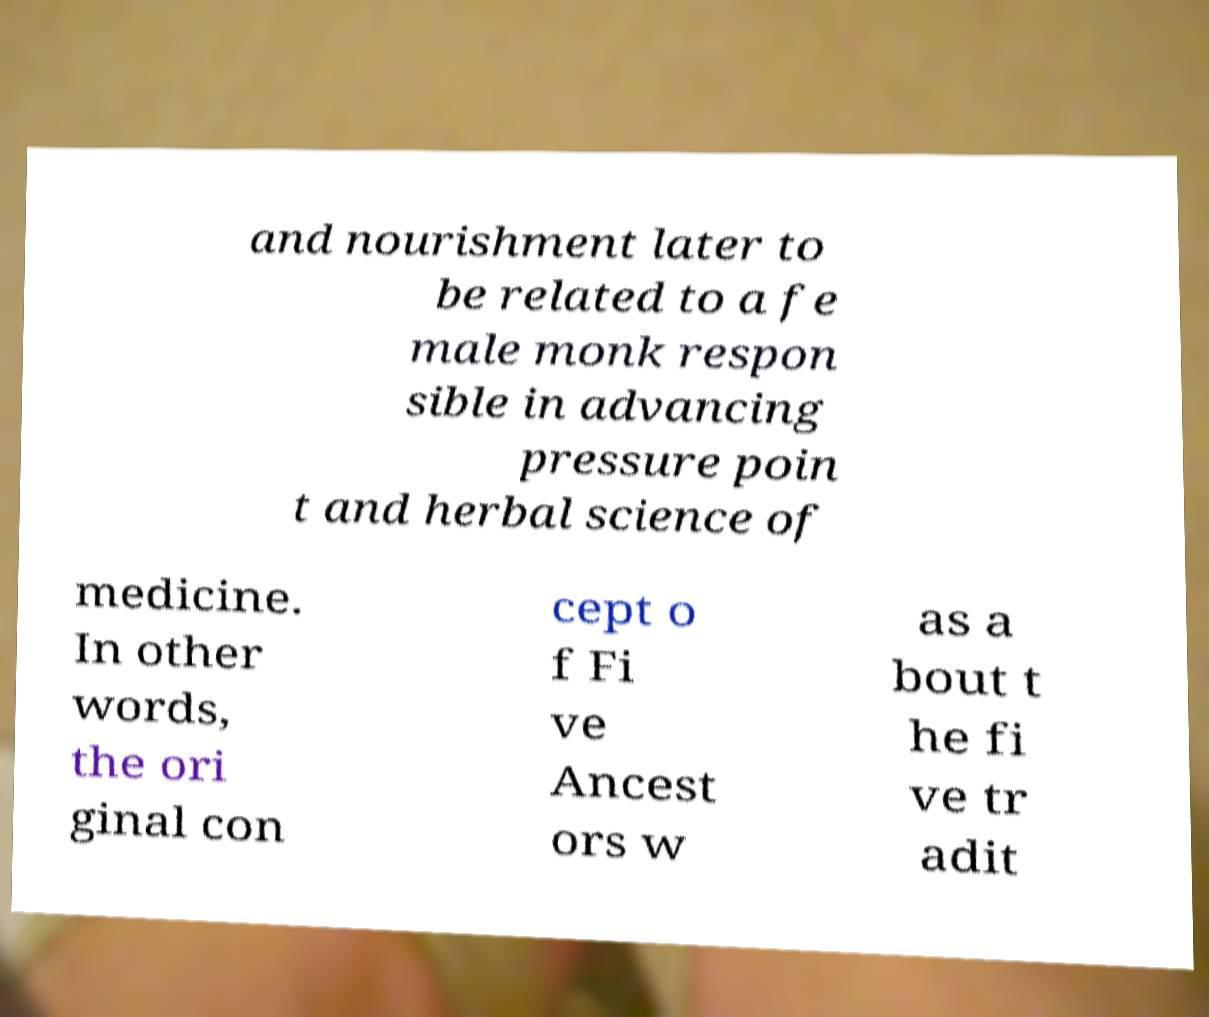Please read and relay the text visible in this image. What does it say? and nourishment later to be related to a fe male monk respon sible in advancing pressure poin t and herbal science of medicine. In other words, the ori ginal con cept o f Fi ve Ancest ors w as a bout t he fi ve tr adit 